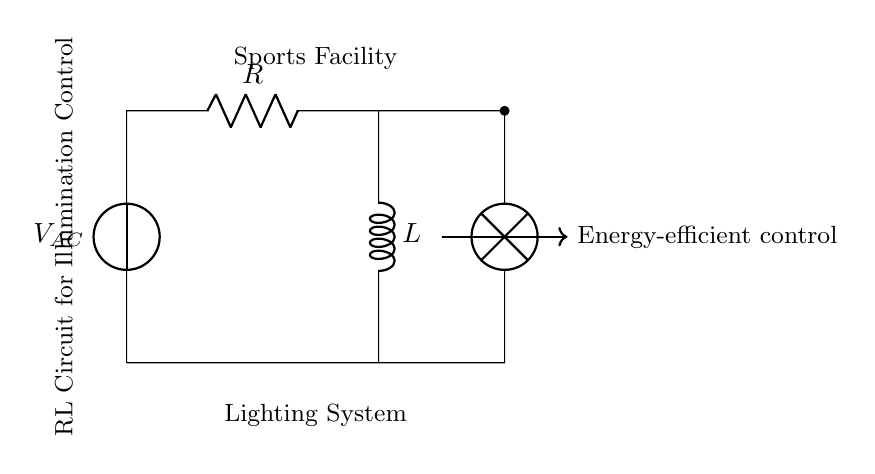What voltage is supplied to the circuit? The voltage is labeled as V_AC and is between the points where the voltage source is connected in the circuit. The value of V_AC can be inferred from the specifications of the power supply used in such systems.
Answer: V_AC What two main components are connected in series in this circuit? The circuit diagram shows a resistor and an inductor connected in series, which can be observed as they are connected one after the other without any branching paths.
Answer: Resistor and Inductor What is the main purpose of the RL circuit in this sports facility? The circuit is designed for energy-efficient control of illumination, as indicated by the label next to the arrows pointing towards the circuit, implying that it regulates lighting systems effectively.
Answer: Energy-efficient control How does the inductor influence the lighting in this circuit? The inductor stores energy in a magnetic field when current flows through it, which helps in smoothing the current and reducing fluctuations, contributing to stable illumination in the lighting system.
Answer: Smooths current What is the characteristic feature of this RL circuit that differs from a purely resistive circuit? Unlike purely resistive circuits, the RL circuit introduces inductance, which impacts the phase relationship between voltage and current, leading to reactive power in the circuit. This effect is crucial for understanding how energy is stored and released in the lighting system.
Answer: Inductance What type of lighting system is typically implemented with this RL circuit design? Such circuits are usually associated with lighting systems in sports facilities, where effective illumination control is essential for various activities, often utilizing energy-efficient technologies.
Answer: Sports Facility Lighting System 